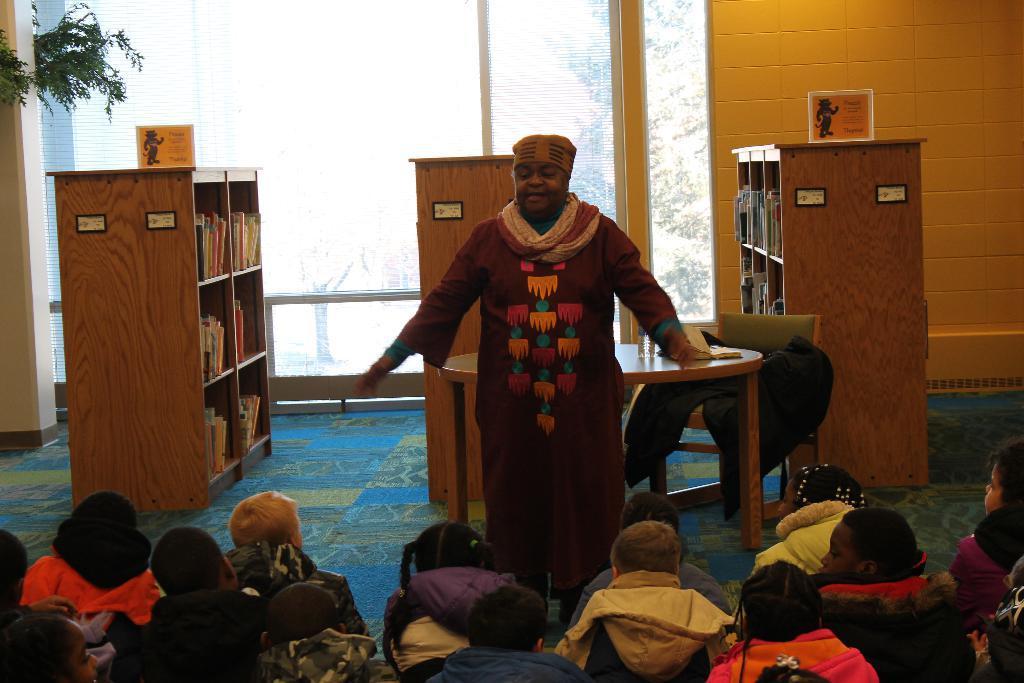Could you give a brief overview of what you see in this image? As we can see in the image there is a window, a man standing over here. Behind him there is a table and there are three racks and there are few people sitting on floor. 